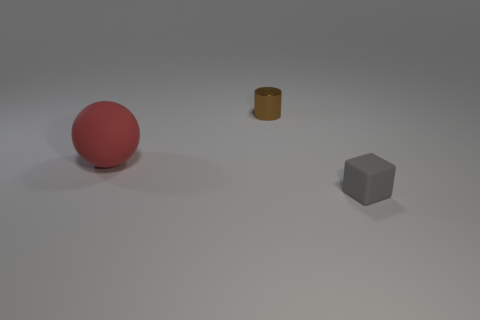Is there anything else that is the same size as the red ball?
Your answer should be compact. No. Do the sphere and the gray rubber object have the same size?
Provide a short and direct response. No. There is a thing that is behind the small gray matte cube and in front of the tiny brown metal object; how big is it?
Offer a terse response. Large. How many matte objects are big brown cubes or brown things?
Your answer should be compact. 0. Is the number of brown things that are in front of the tiny gray rubber thing greater than the number of shiny things?
Provide a succinct answer. No. There is a tiny thing behind the rubber sphere; what material is it?
Your answer should be very brief. Metal. How many tiny gray blocks have the same material as the small brown object?
Your response must be concise. 0. There is a object that is both behind the gray object and in front of the small brown cylinder; what is its shape?
Provide a succinct answer. Sphere. What number of things are either objects on the left side of the shiny cylinder or objects left of the small shiny thing?
Your answer should be compact. 1. Is the number of brown metallic cylinders in front of the big rubber ball the same as the number of small objects that are behind the small gray object?
Offer a very short reply. No. 